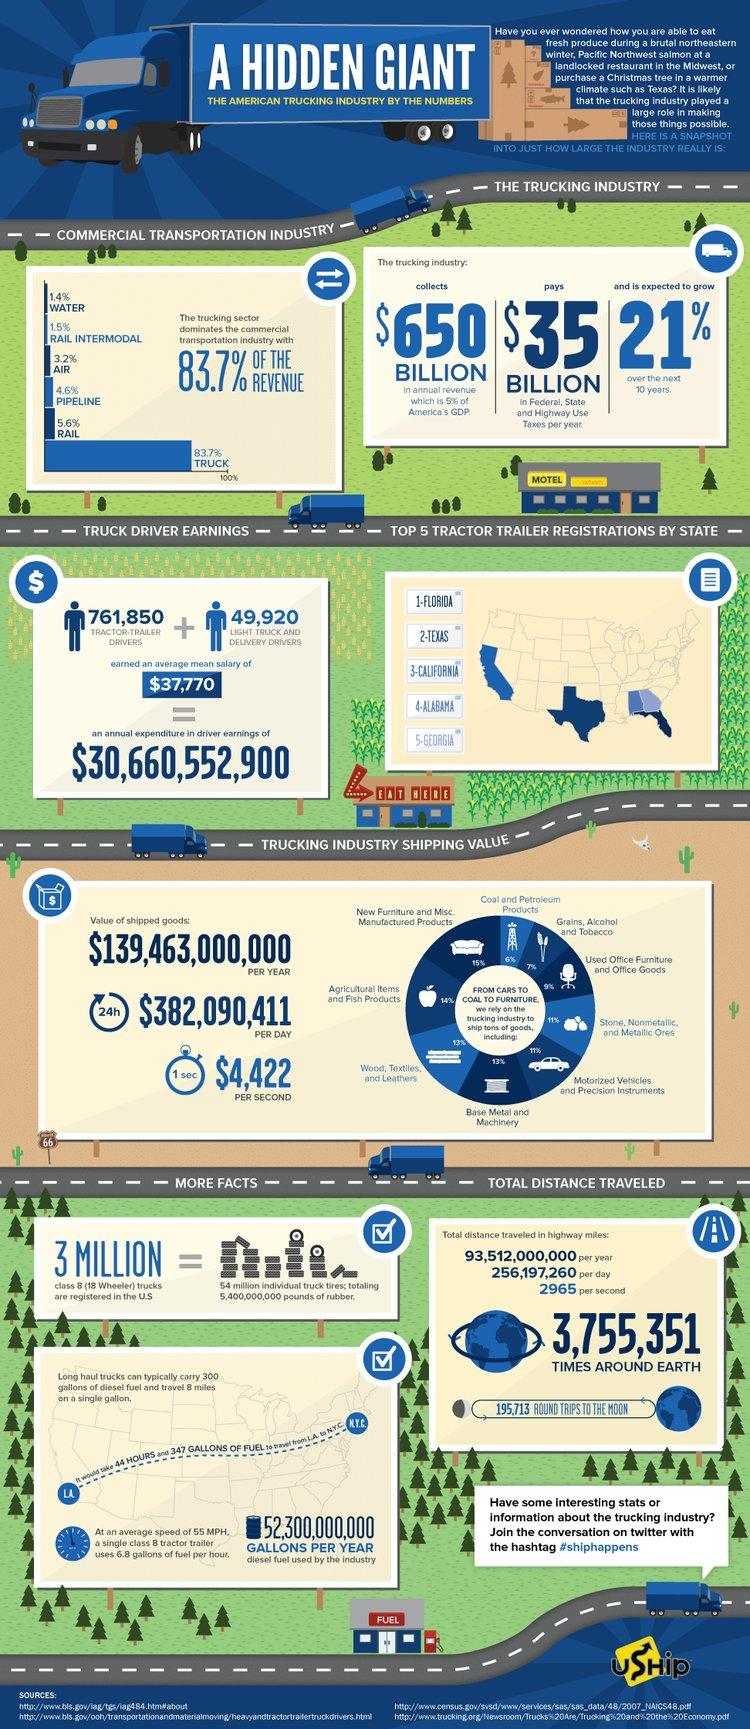Highlight a few significant elements in this photo. Approximately 6% of the total shipped goods are composed of coal and petroleum products. Out of all shipped goods, approximately 7% are grains, alcohol, and tobacco. Approximately 13% of all shipments are related to base metals and machinery. The least percentage of shipped products consists of coal and petroleum products. The most commonly shipped goods are new furniture and miscellaneous manufactured products. 